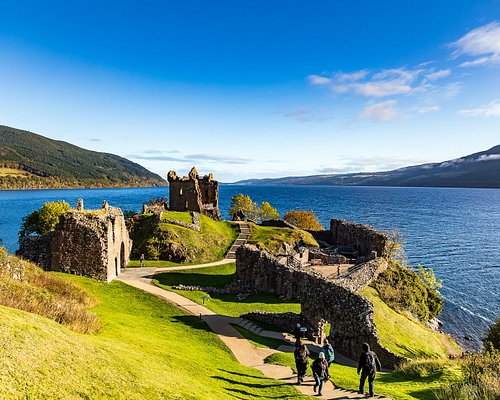What kind of wildlife might you encounter around Loch Ness? Around Loch Ness, you could encounter a variety of wildlife. The loch itself is home to fish like trout and salmon, and its shores are frequented by otters. Bird watchers might spot species such as ospreys, golden eagles, and peregrine falcons. The surrounding forests and hills are habitat to red deer, pine martens, and occasionally, a glimpse of the elusive Scottish wildcat. This rich biodiversity makes Loch Ness a fascinating destination for nature enthusiasts. 